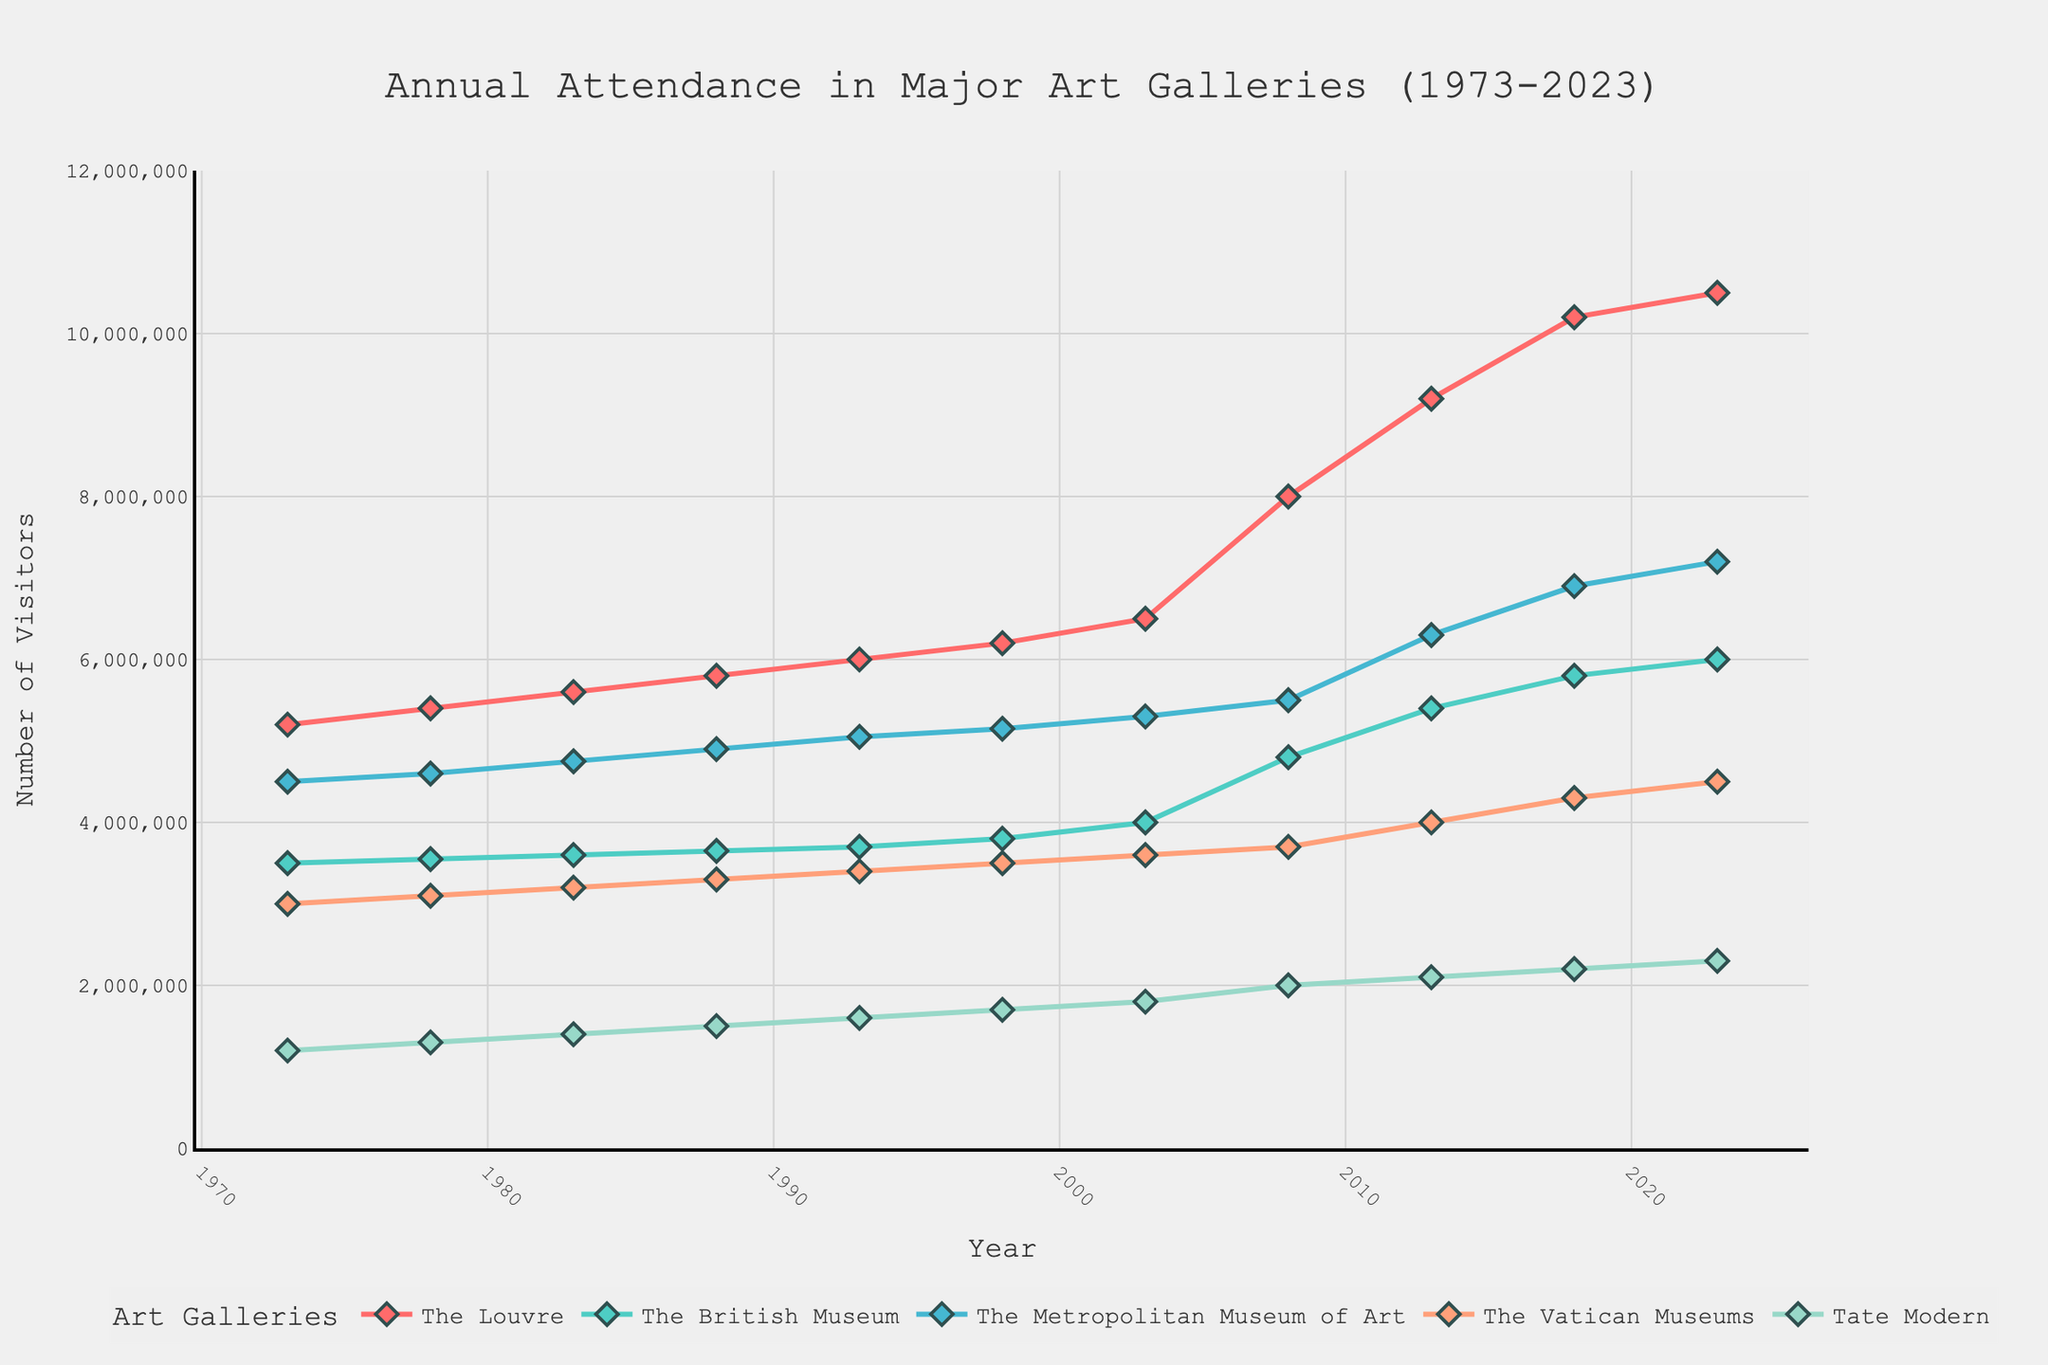What is the title of the plot? The title of the plot is located at the top center of the figure, and it reads "Annual Attendance in Major Art Galleries (1973-2023)."
Answer: Annual Attendance in Major Art Galleries (1973-2023) What information does the y-axis represent? The y-axis is labeled with "Number of Visitors," indicating that it shows the number of visitors to each art gallery per year.
Answer: Number of Visitors How many art galleries are represented in the plot? The legend at the bottom of the plot lists the names of the art galleries, which are The Louvre, The British Museum, The Metropolitan Museum of Art, The Vatican Museums, and Tate Modern. There are five art galleries represented in the plot.
Answer: Five Which art gallery had the highest number of visitors in 2023? By examining the points at the year 2023 on the plot, The Louvre, denoted by its trace, appears to have the highest number of visitors at approximately 10,500,000.
Answer: The Louvre Between which years did Tate Modern experience the largest increase in annual attendance? By tracing the line for Tate Modern, the largest increase in attendance appears between the years 2003 and 2008, jumping from 1,800,000 to 2,000,000 visitors.
Answer: 2003 to 2008 How does the attendance trend of the Vatican Museums compare to the British Museum from 1973 to 2023? By comparing the lines for the Vatican Museums and the British Museum, both have increasing trends. The Vatican Museums started lower but had a more steep increase especially noticeable after the 2010s, while the British Museum had a steadier, more gradual increase.
Answer: Vatican Museums increased more steeply after the 2010s What was the attendance at The Louvre in 2018? By locating the 2018 marker on The Louvre's line, the attendance was around 10,200,000.
Answer: 10,200,000 Which gallery had the smallest attendance increase from 1973 to 1983? By examining the slopes of all the lines from 1973 to 1983, Tate Modern had the smallest increase in attendance, starting from 1,200,000 and reaching 1,400,000.
Answer: Tate Modern What is the difference in visitors between The Louvre and The Metropolitan Museum of Art in 2023? In 2023, The Louvre had approximately 10,500,000 visitors, and The Metropolitan Museum of Art had about 7,200,000 visitors, leading to a difference of 10,500,000 - 7,200,000 = 3,300,000.
Answer: 3,300,000 When did The Louvre first surpass 8,000,000 annual visitors? By looking at the data points for The Louvre, it first surpassed 8,000,000 annual visitors in 2008.
Answer: 2008 